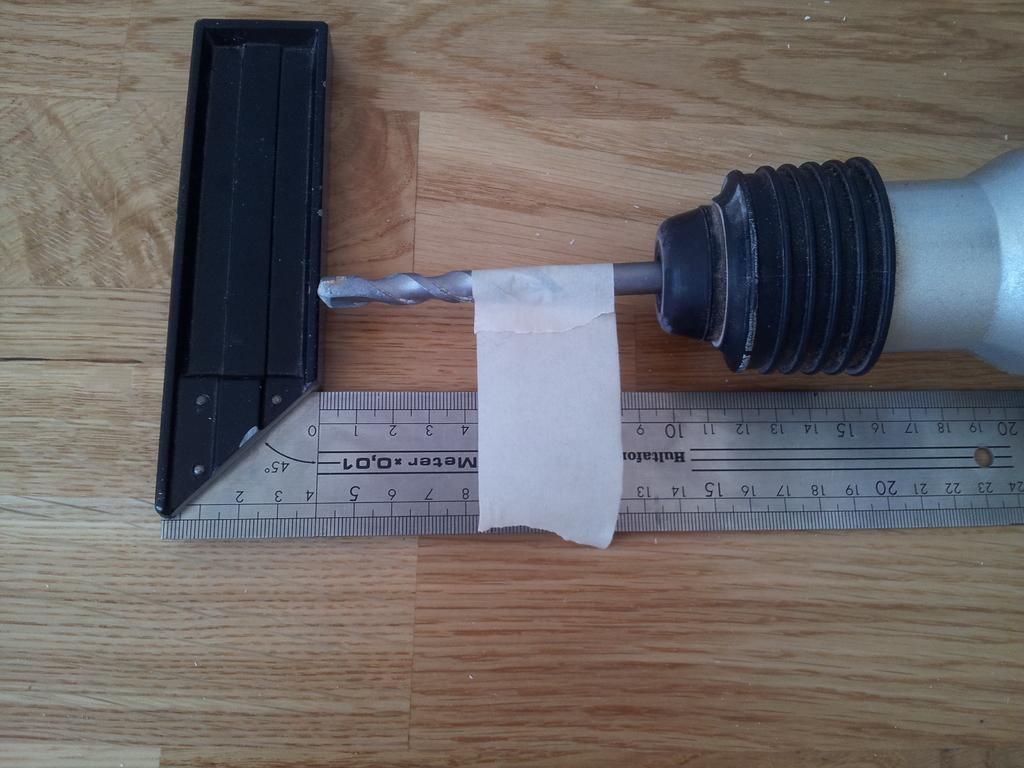<image>
Share a concise interpretation of the image provided. a drill bit is taped to a measuring tool at 4.5 inches 